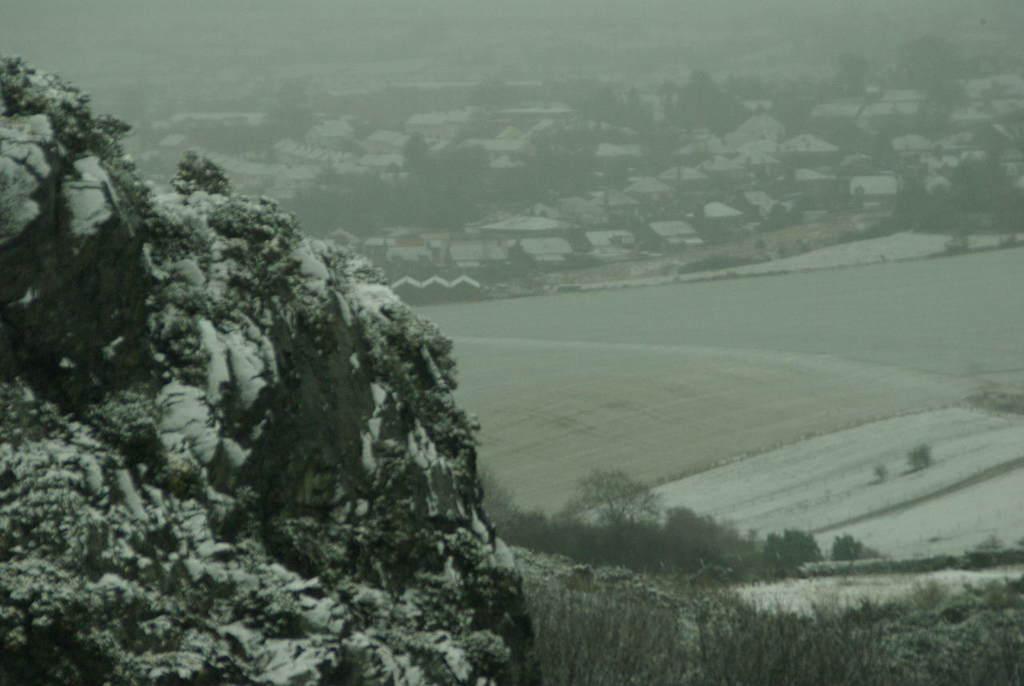In one or two sentences, can you explain what this image depicts? In this picture I can observe an open land in the middle of the picture. On the left side I can observe hill. In the background I can observe houses. There is some snow on the hill. 